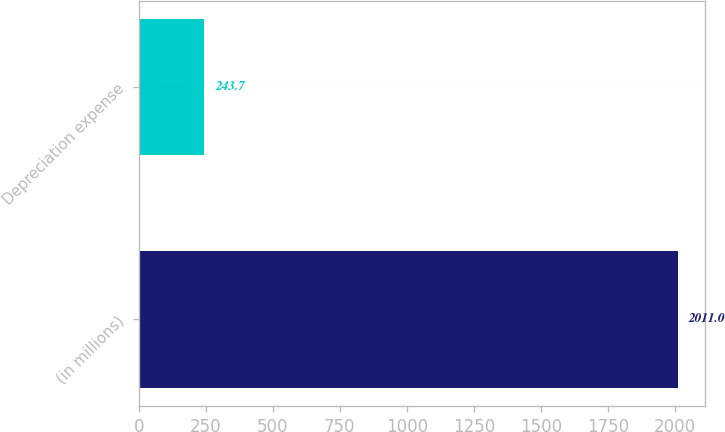<chart> <loc_0><loc_0><loc_500><loc_500><bar_chart><fcel>(in millions)<fcel>Depreciation expense<nl><fcel>2011<fcel>243.7<nl></chart> 